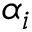Convert formula to latex. <formula><loc_0><loc_0><loc_500><loc_500>\alpha _ { i }</formula> 